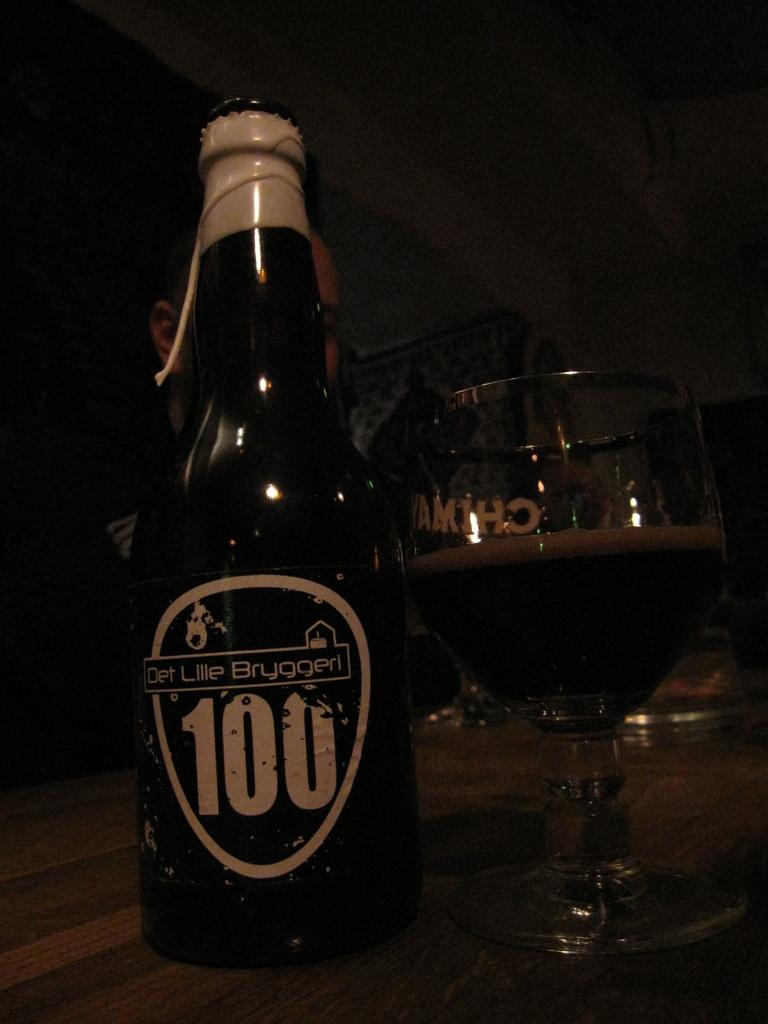Provide a one-sentence caption for the provided image. AN AMBER BOTTLE OF DET LILLE BRUGGERI BEER AND GLASS. 